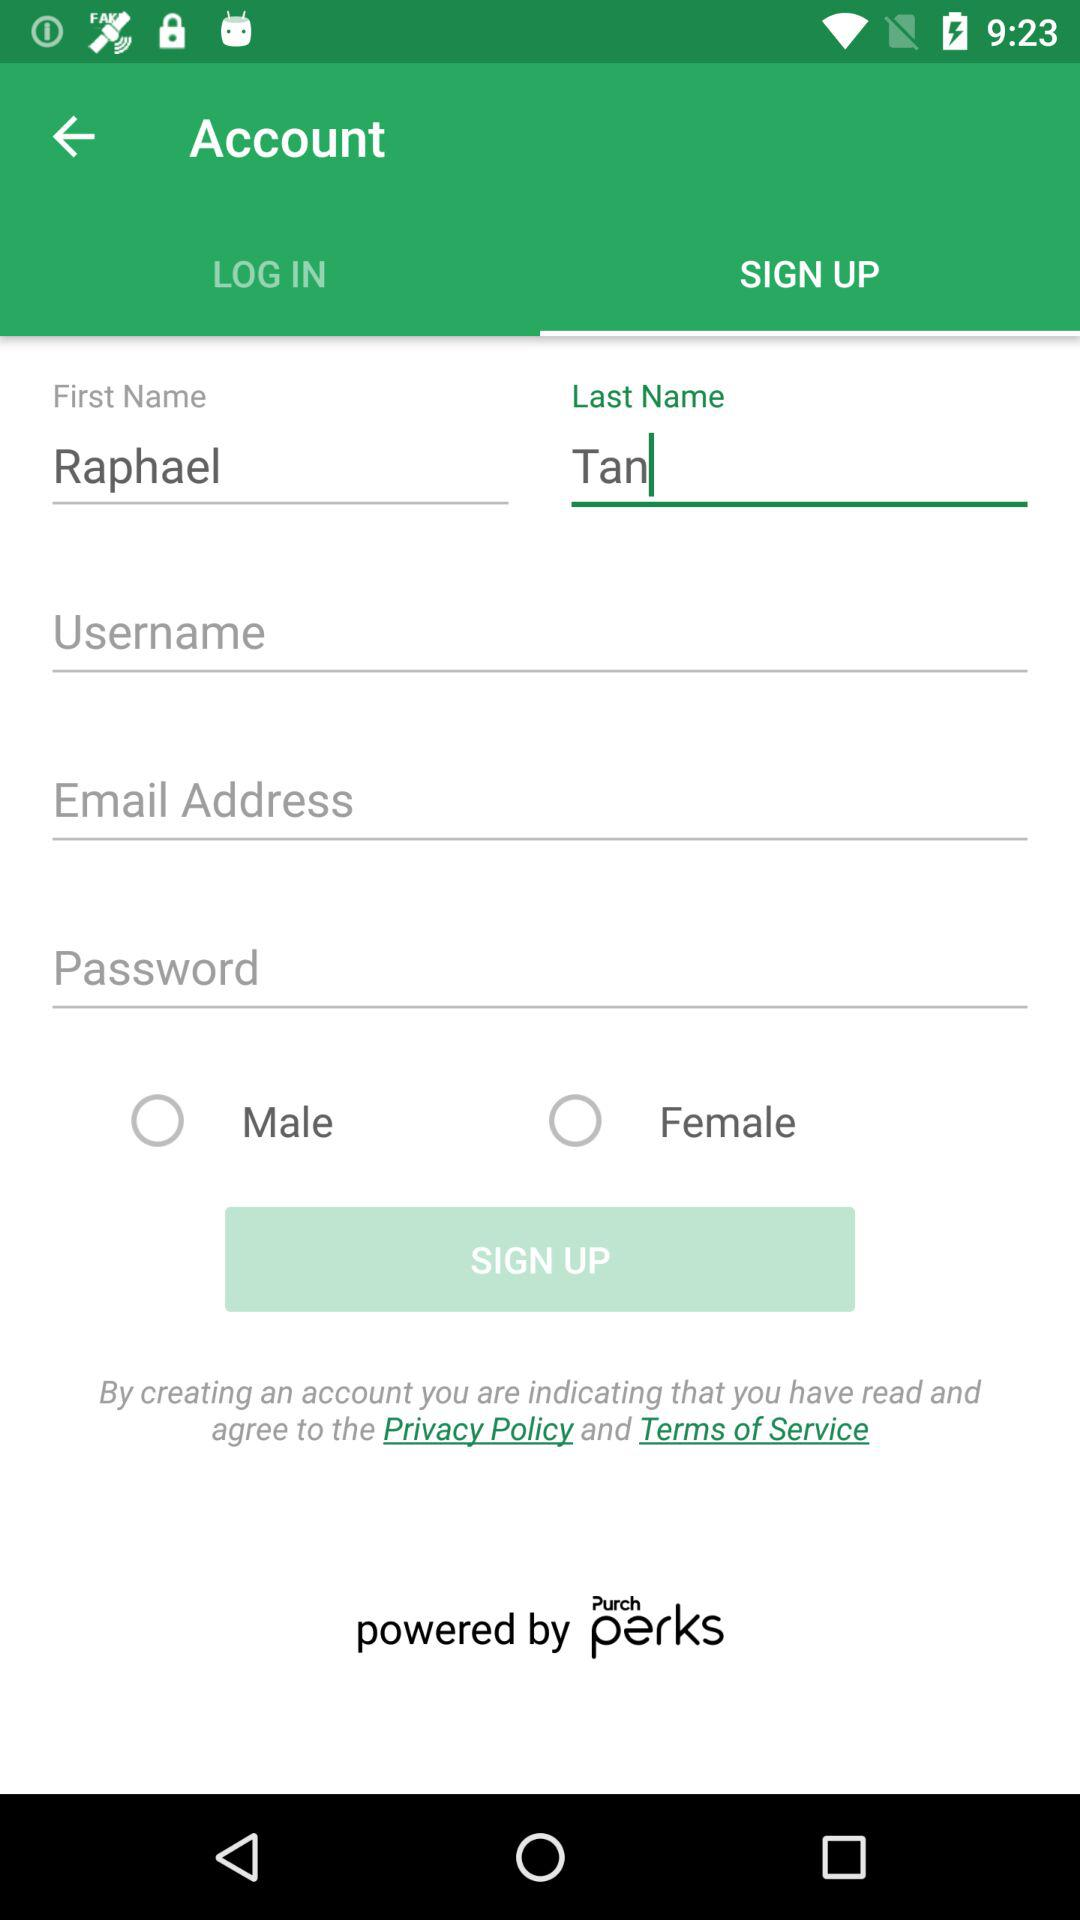What is the selected tab? The selected tab is "SIGN UP". 